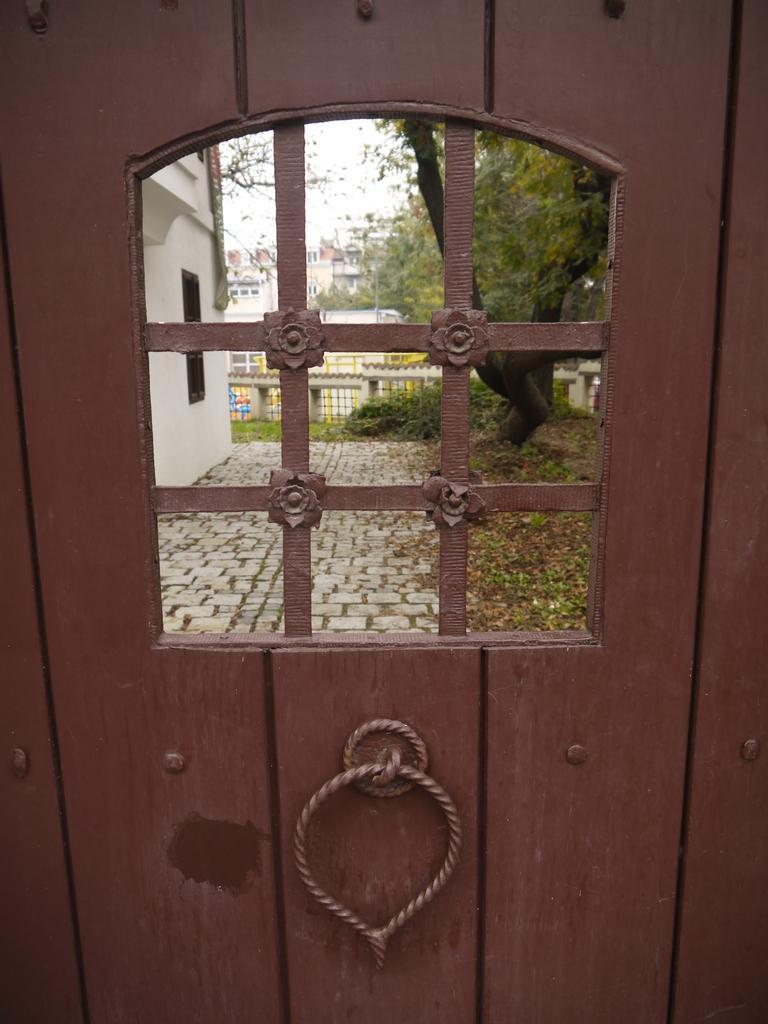Can you describe this image briefly? In this picture I can see a wooden door, from the door I can see buildings trees a cloudy sky. 